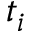Convert formula to latex. <formula><loc_0><loc_0><loc_500><loc_500>t _ { i }</formula> 